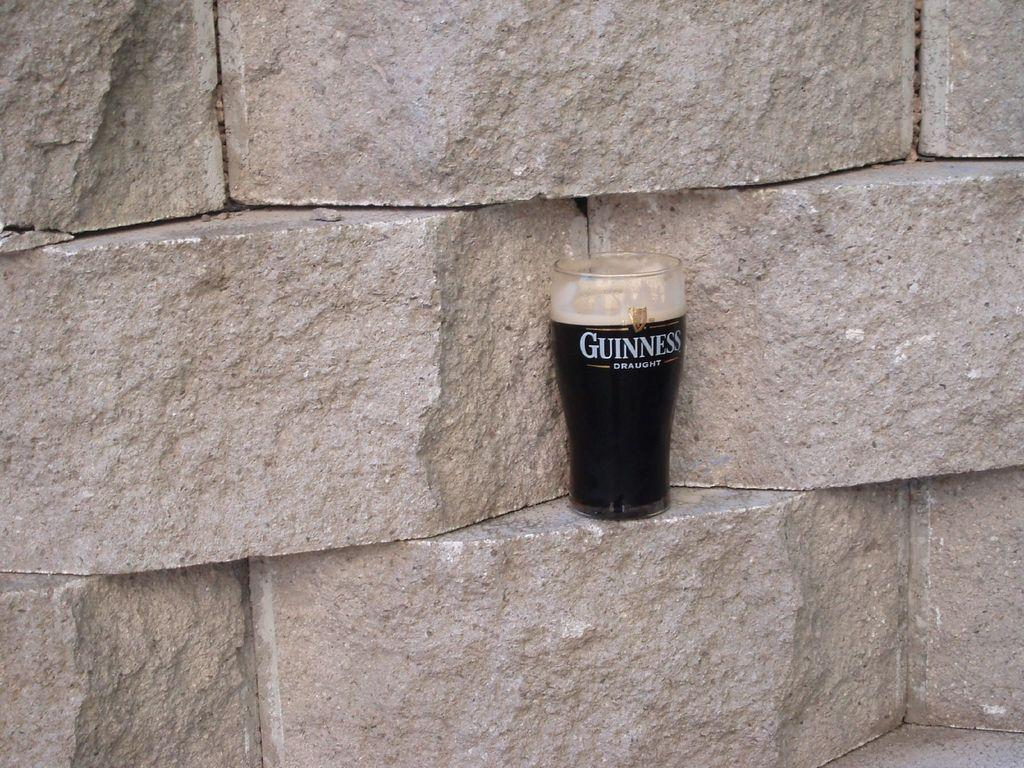<image>
Render a clear and concise summary of the photo. A full glass of Guinness Draught beer sits on concrete blocks. 